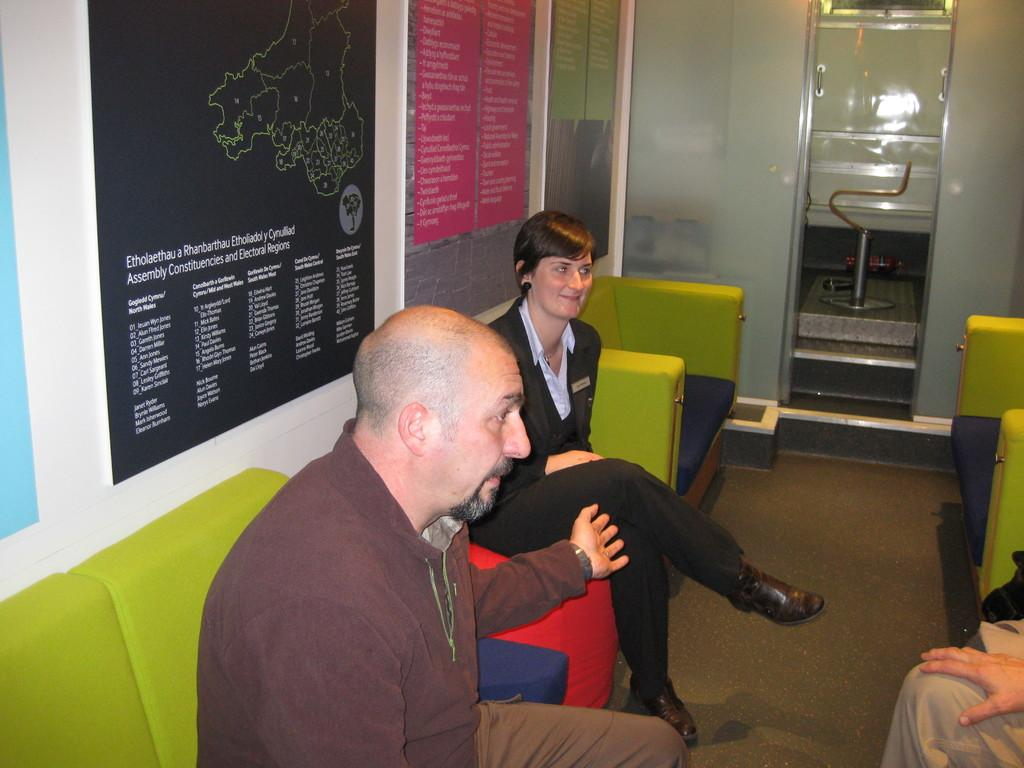<image>
Provide a brief description of the given image. Three people sitting on couches discussing between themselves under a wall map of Etholaethau a Rhanbarthau Etholiaddol Cyrbullliad. 